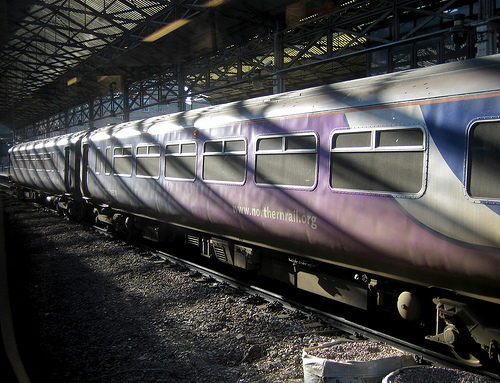<image>
Is there a window behind the train? No. The window is not behind the train. From this viewpoint, the window appears to be positioned elsewhere in the scene. 